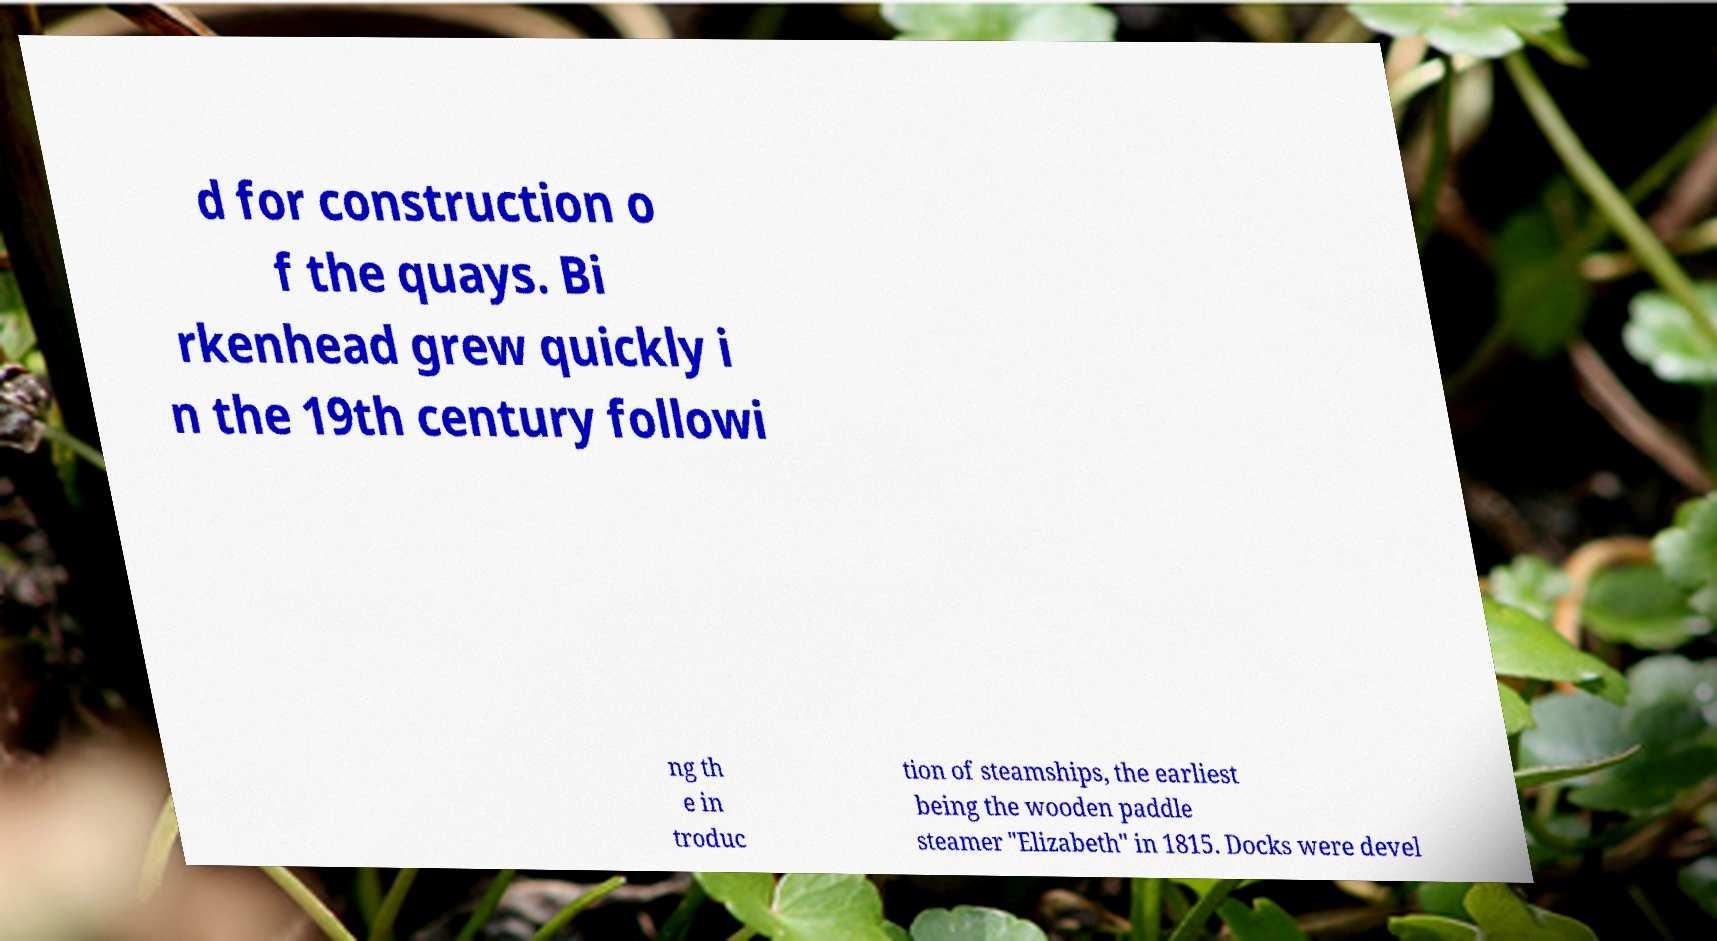Can you accurately transcribe the text from the provided image for me? d for construction o f the quays. Bi rkenhead grew quickly i n the 19th century followi ng th e in troduc tion of steamships, the earliest being the wooden paddle steamer "Elizabeth" in 1815. Docks were devel 